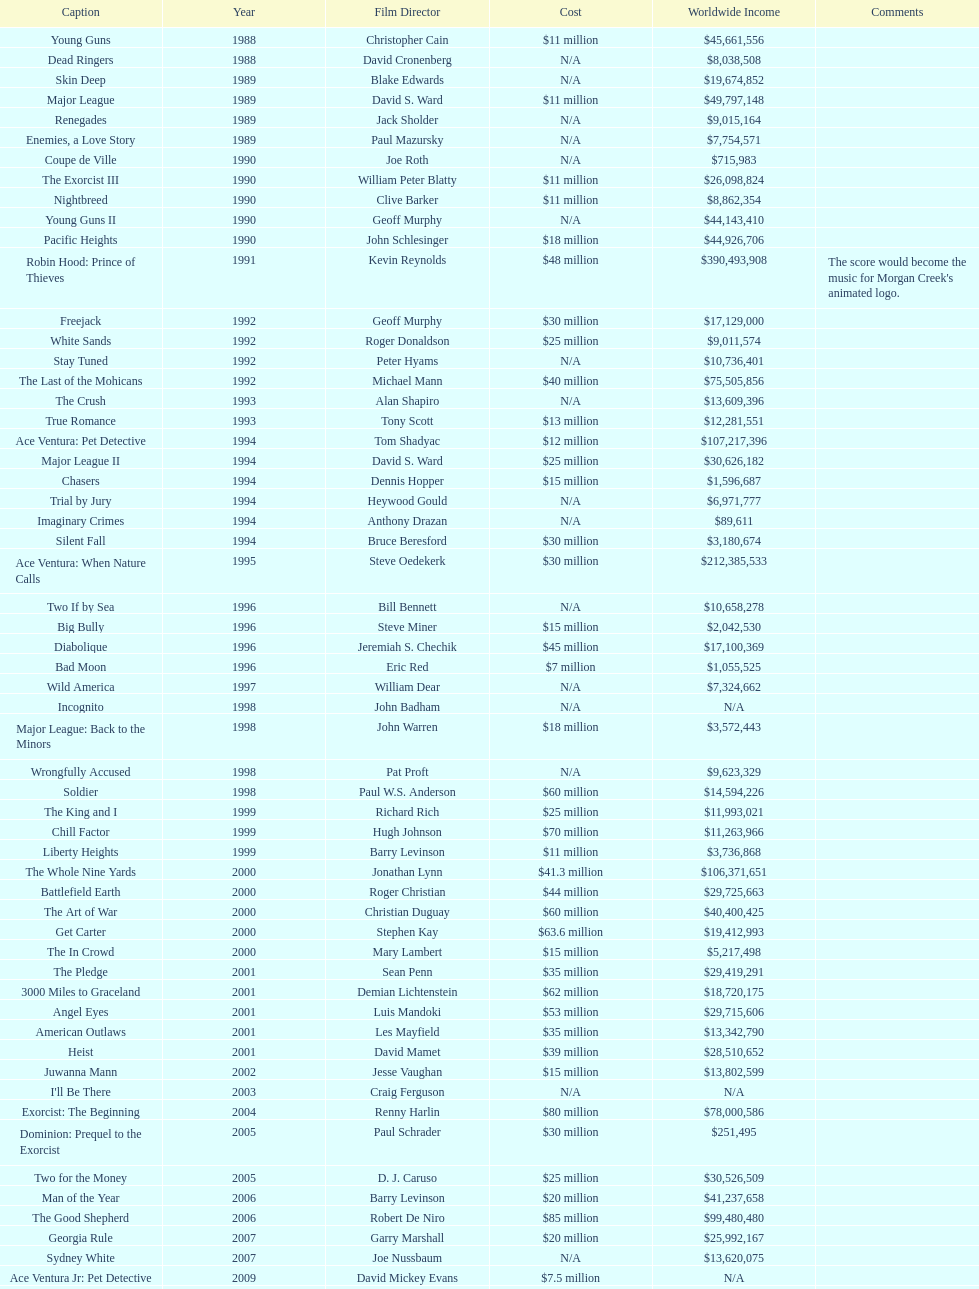Following young guns, which film had the identical budget? Major League. 